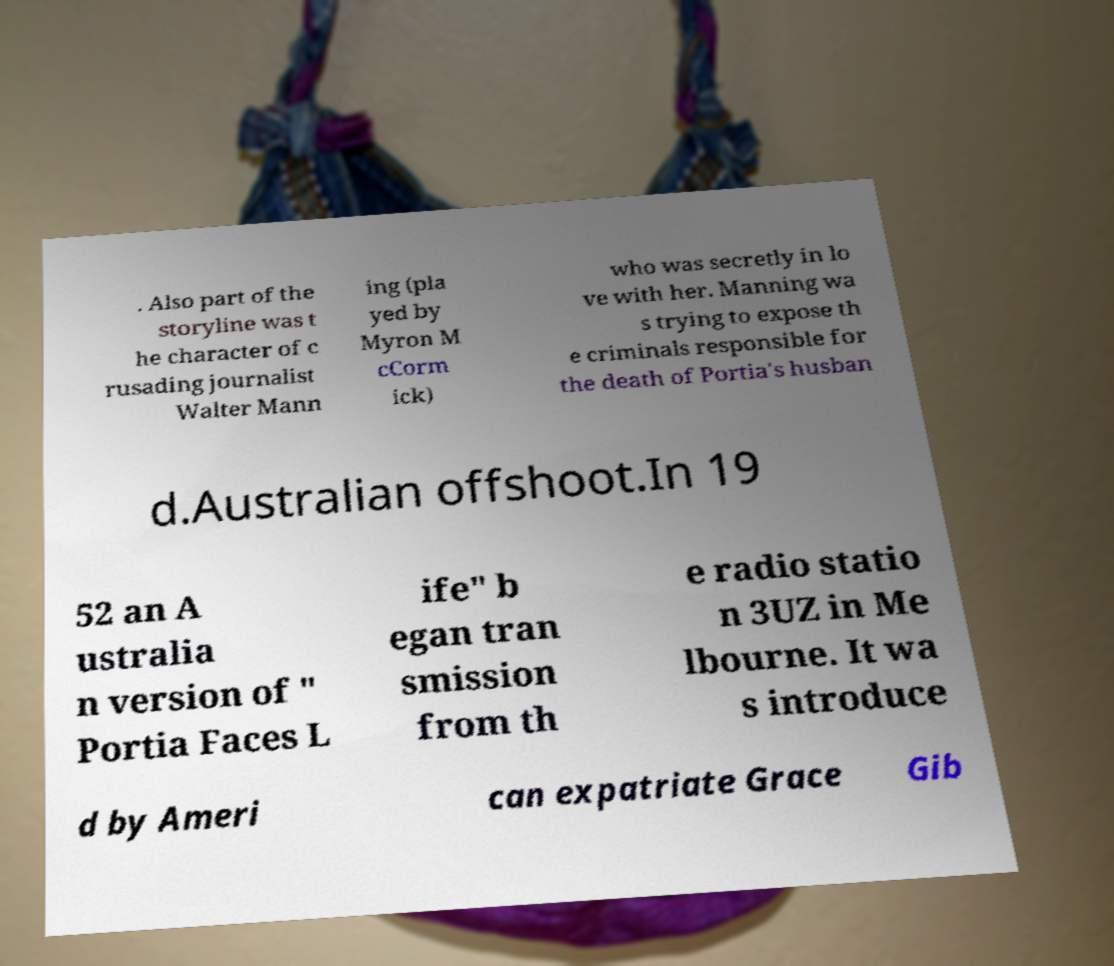Can you accurately transcribe the text from the provided image for me? . Also part of the storyline was t he character of c rusading journalist Walter Mann ing (pla yed by Myron M cCorm ick) who was secretly in lo ve with her. Manning wa s trying to expose th e criminals responsible for the death of Portia's husban d.Australian offshoot.In 19 52 an A ustralia n version of " Portia Faces L ife" b egan tran smission from th e radio statio n 3UZ in Me lbourne. It wa s introduce d by Ameri can expatriate Grace Gib 